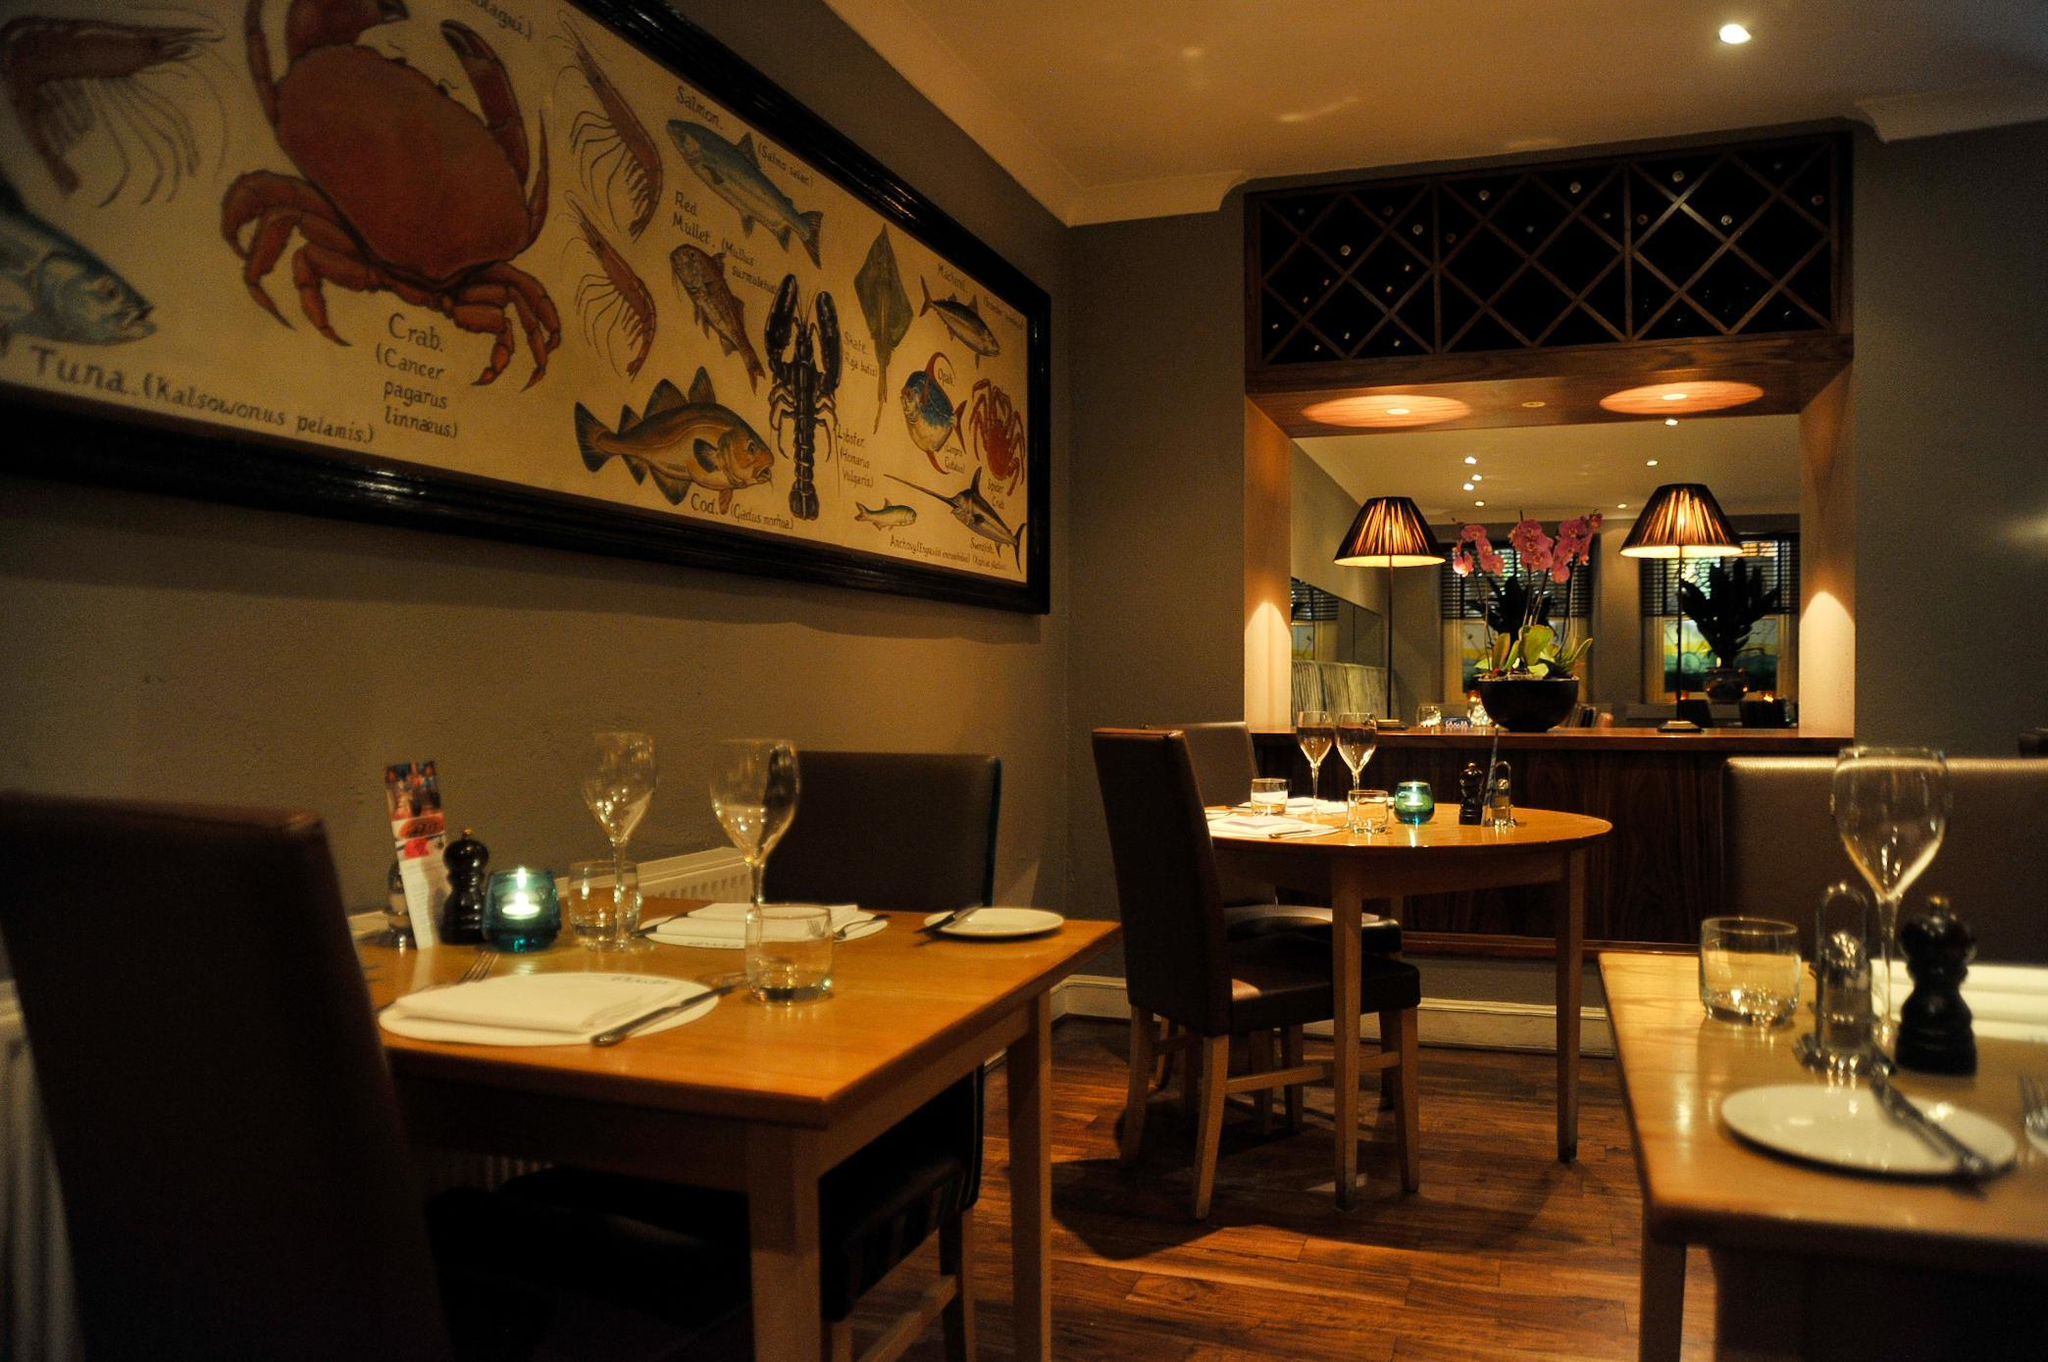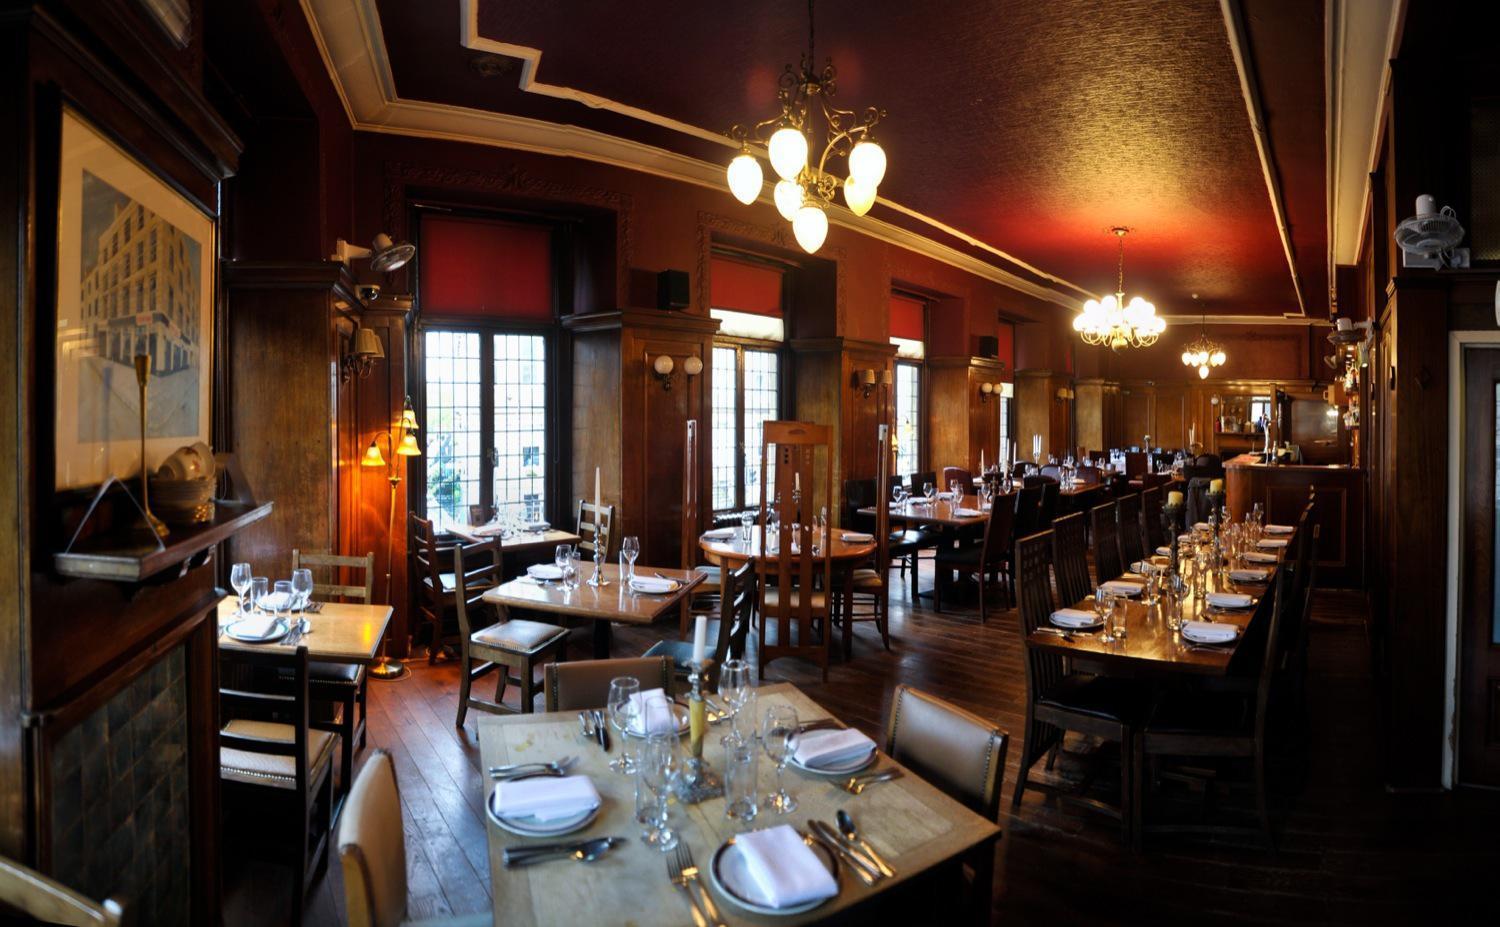The first image is the image on the left, the second image is the image on the right. For the images displayed, is the sentence "One restaurant interior features multiple cyclindrical black and red suspended lights over the seating area." factually correct? Answer yes or no. No. The first image is the image on the left, the second image is the image on the right. Analyze the images presented: Is the assertion "there is a painted tray ceiling with lighting hanging from it" valid? Answer yes or no. Yes. 